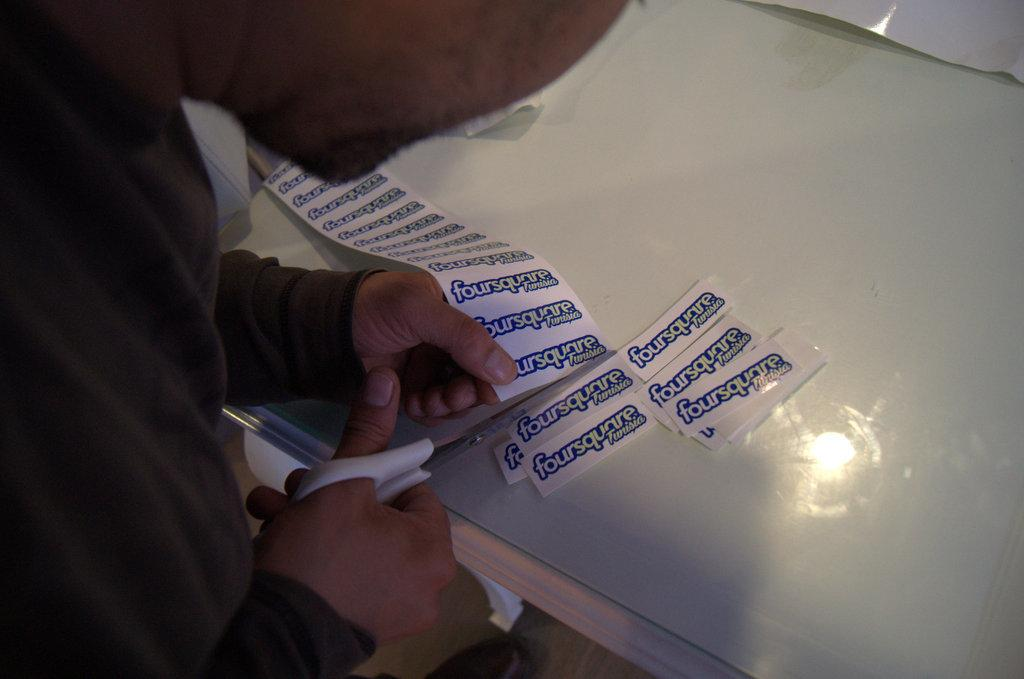Who is present in the image? There is a person in the image. What is the person holding in the image? The person is holding scissors. What is the person doing with the scissors? The person is cutting a paper into small pieces. What is the surface on which the person is working? There is a table in the image. What else can be seen on the table? There is a glass slab on the table. What is the person's opinion on the journey they took last week? There is no information about a journey or the person's opinion in the image. 